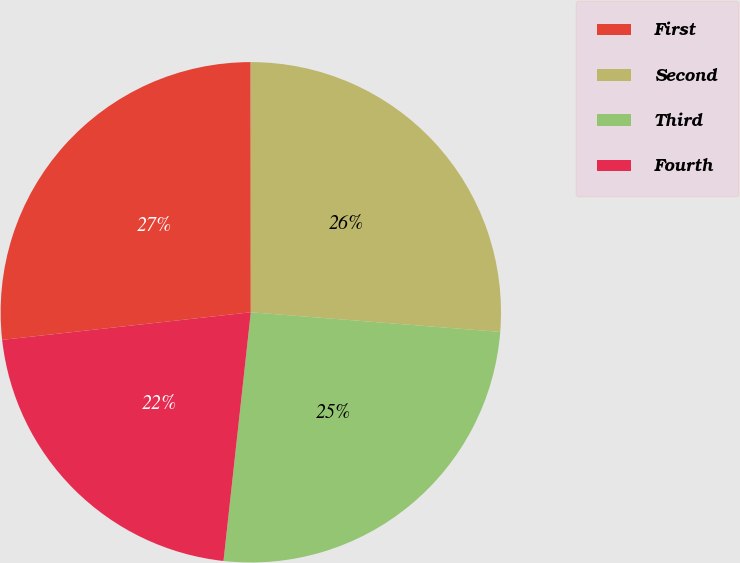Convert chart. <chart><loc_0><loc_0><loc_500><loc_500><pie_chart><fcel>First<fcel>Second<fcel>Third<fcel>Fourth<nl><fcel>26.75%<fcel>26.26%<fcel>25.49%<fcel>21.5%<nl></chart> 